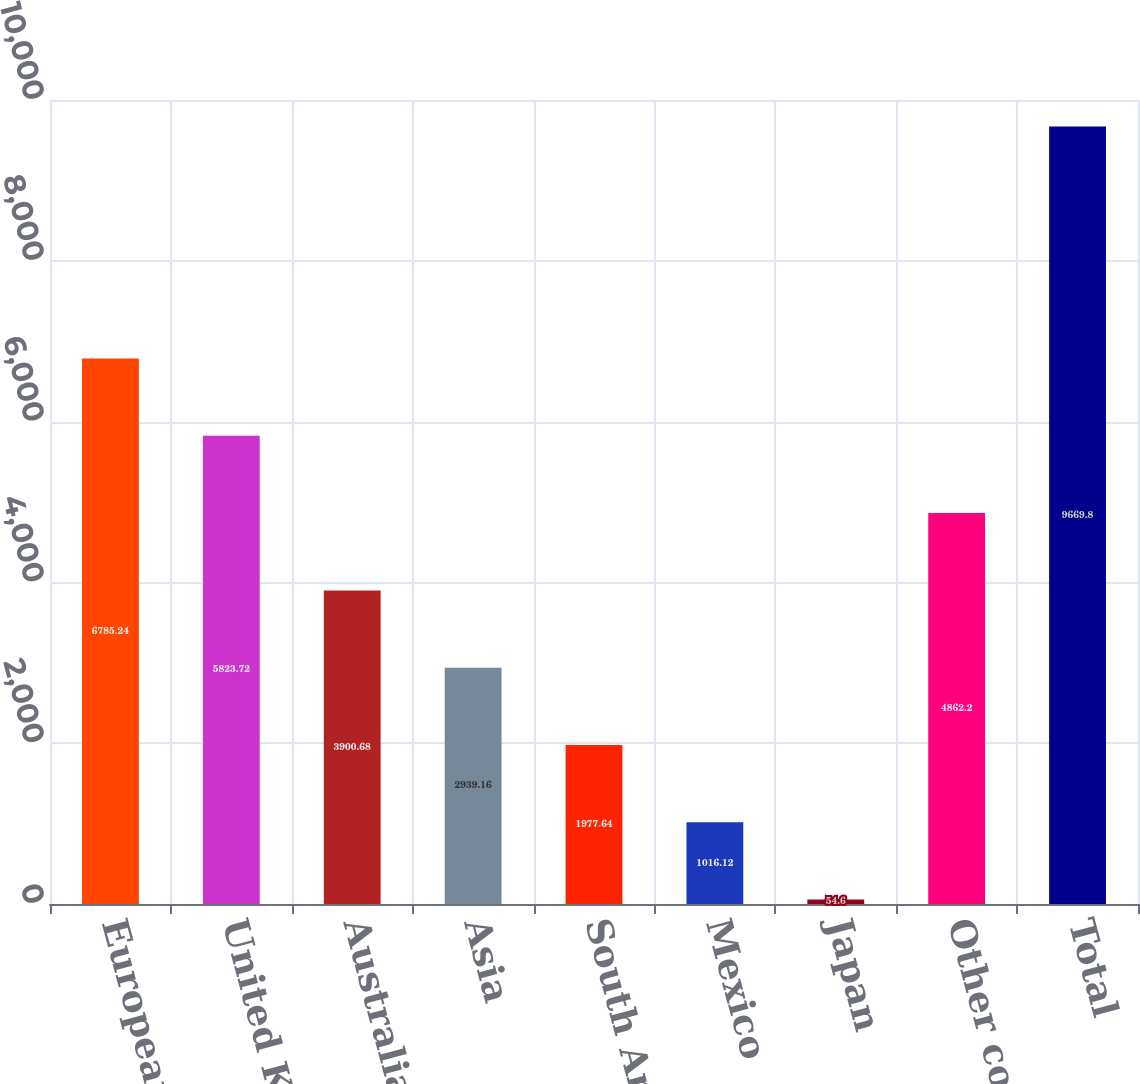Convert chart to OTSL. <chart><loc_0><loc_0><loc_500><loc_500><bar_chart><fcel>European Union<fcel>United Kingdom<fcel>Australia<fcel>Asia<fcel>South America<fcel>Mexico<fcel>Japan<fcel>Other countries (1)<fcel>Total<nl><fcel>6785.24<fcel>5823.72<fcel>3900.68<fcel>2939.16<fcel>1977.64<fcel>1016.12<fcel>54.6<fcel>4862.2<fcel>9669.8<nl></chart> 